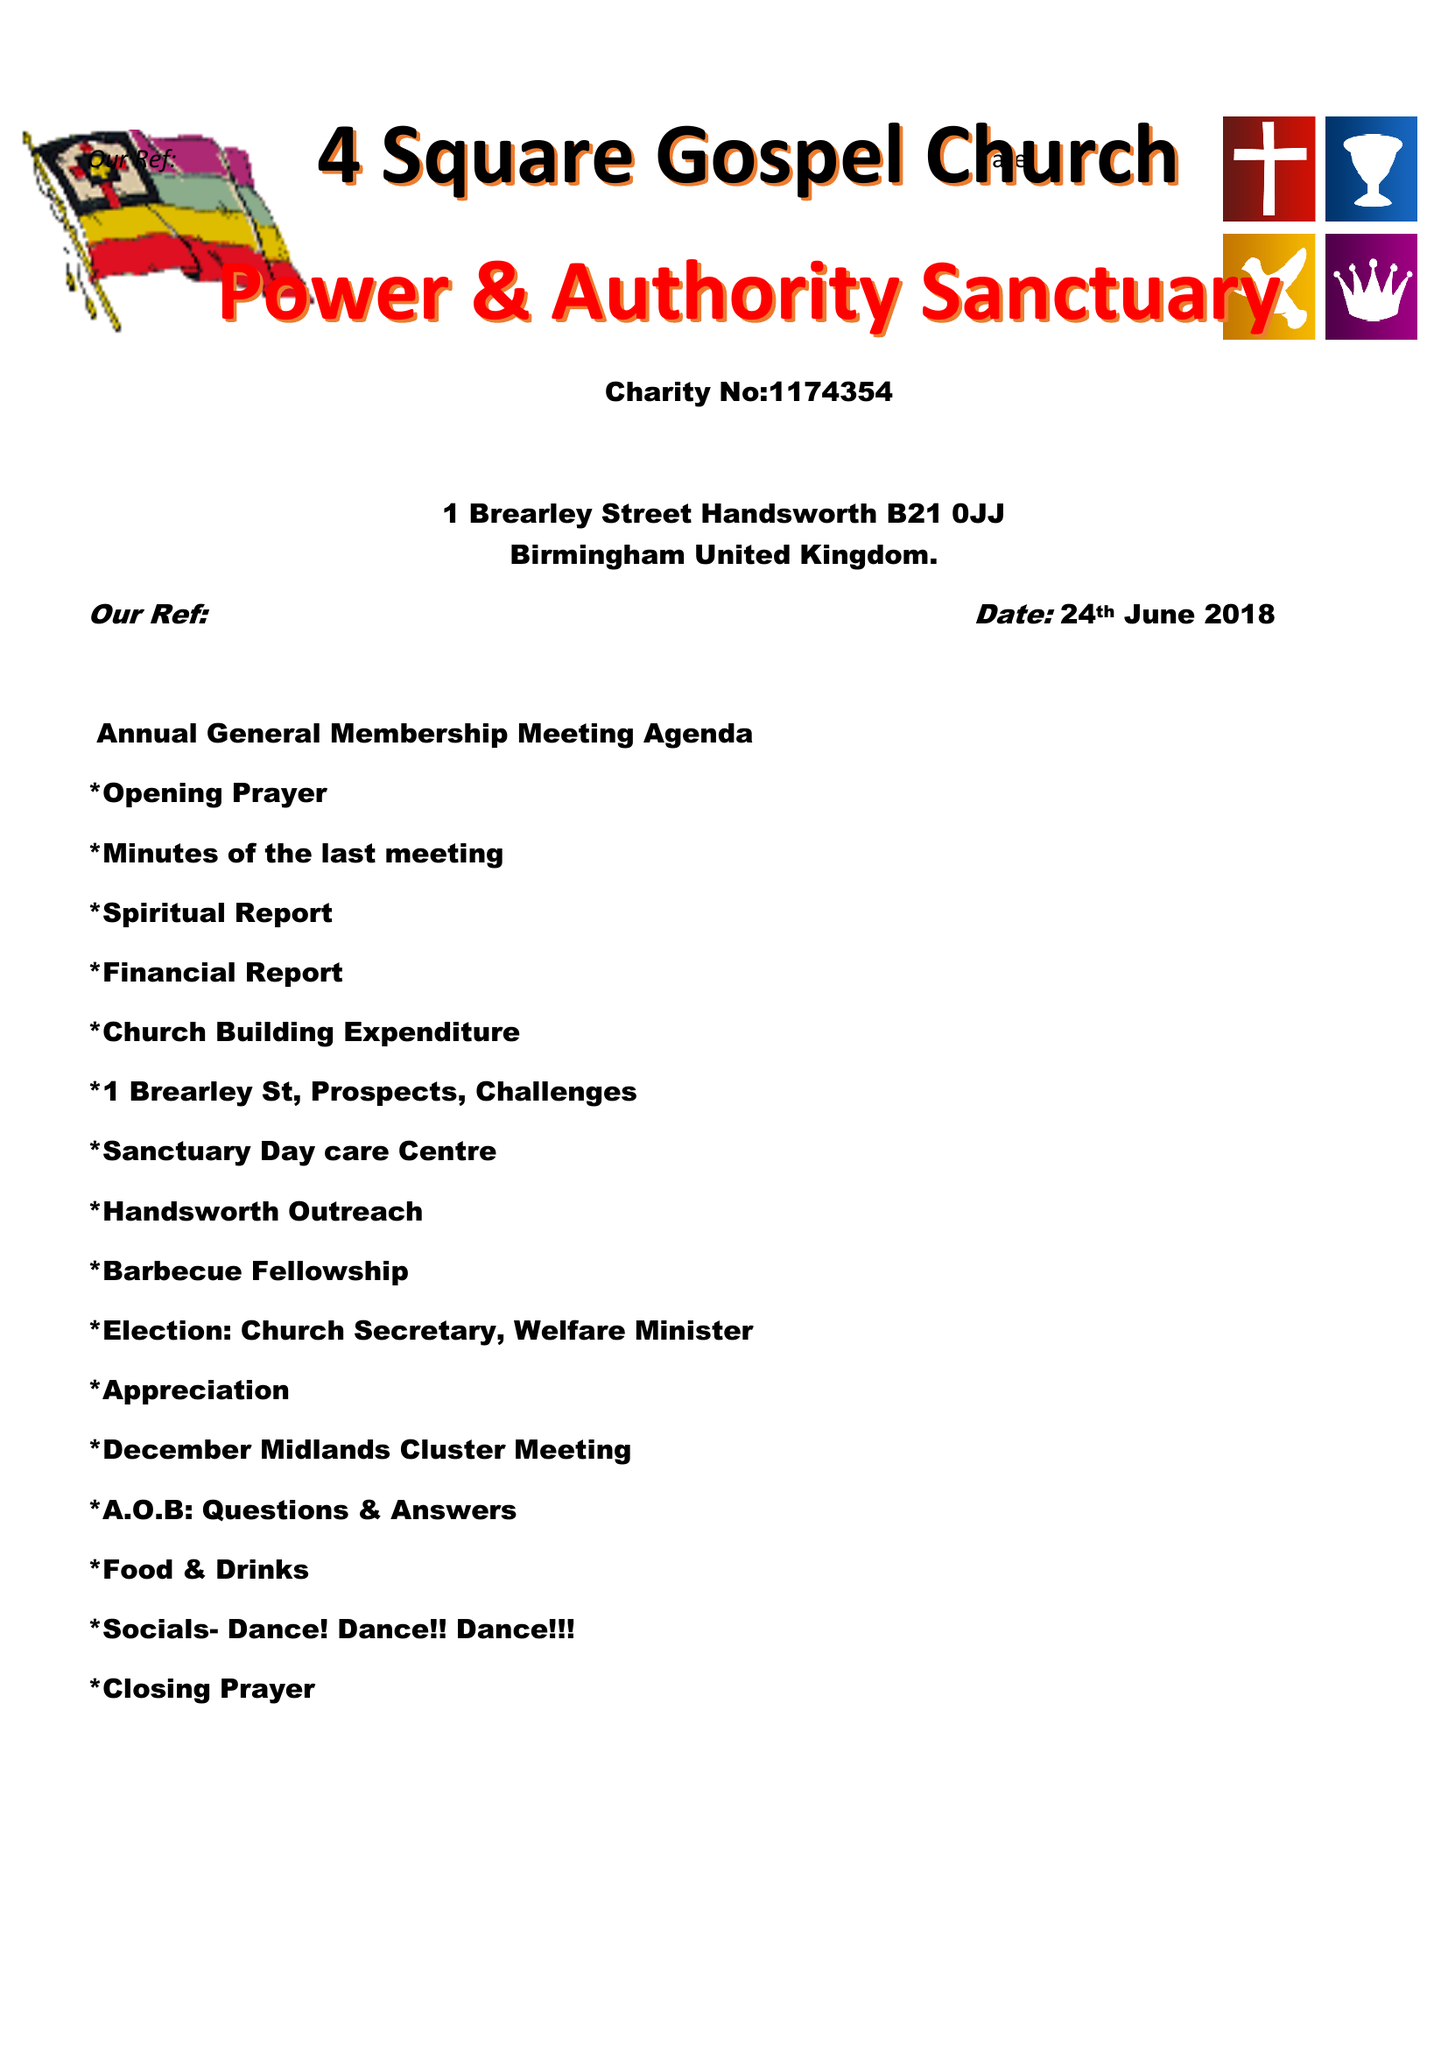What is the value for the spending_annually_in_british_pounds?
Answer the question using a single word or phrase. 10790.00 